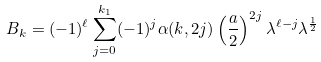Convert formula to latex. <formula><loc_0><loc_0><loc_500><loc_500>B _ { k } = ( - 1 ) ^ { \ell } \sum ^ { k _ { 1 } } _ { j = 0 } ( - 1 ) ^ { j } \alpha ( k , 2 j ) \left ( \frac { a } { 2 } \right ) ^ { 2 j } \lambda ^ { \ell - j } \lambda ^ { \frac { 1 } { 2 } }</formula> 